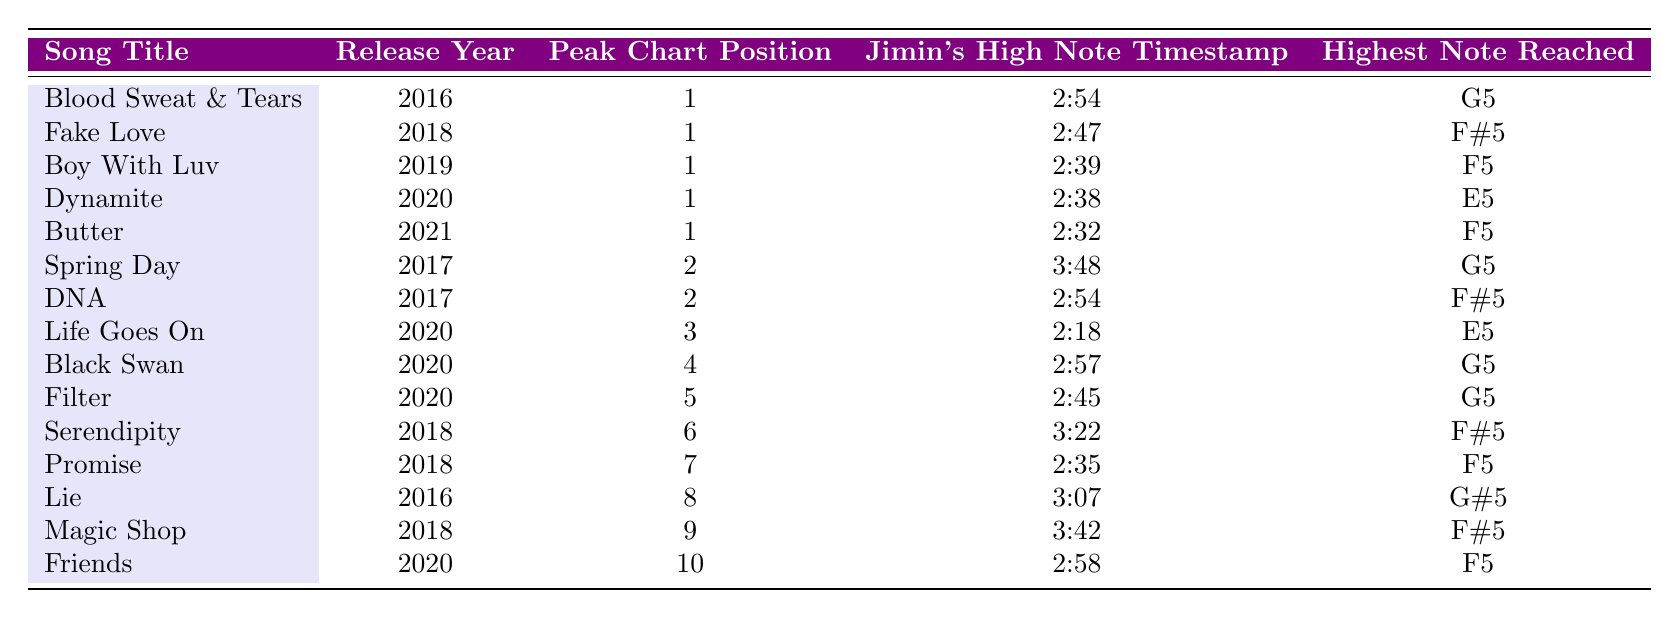What is the highest chart position achieved by "Blood Sweat & Tears"? The table lists the peak chart position for each song. For "Blood Sweat & Tears," the peak chart position is 1.
Answer: 1 Which song features Jimin's high note at the timestamp of 2:45? By looking at the timestamp column, the song "Filter" has Jimin's high note at 2:45.
Answer: Filter Which songs with a peak position of 2 includes Jimin's high notes? There are two songs with a peak position of 2: "Spring Day" and "DNA".
Answer: Spring Day, DNA What is the highest note reached in "Serendipity"? The table indicates that "Serendipity" features Jimin's highest note at F#5.
Answer: F#5 Which song released in 2020 had the lowest peak chart position? Looking at the year 2020, "Life Goes On" has the lowest peak position at 3 among the songs released that year.
Answer: Life Goes On If you sum the chart positions of all songs featuring Jimin's high notes, what is the total? By adding the peak positions (1 + 1 + 1 + 1 + 1 + 2 + 2 + 3 + 4 + 5 + 6 + 7 + 8 + 9 + 10), the total is 60.
Answer: 60 What year did "Dynamite" get released? The table states that "Dynamite" was released in 2020.
Answer: 2020 Which song has the highest note of G#5 and what is its peak position? According to the table, "Lie" has the highest note of G#5 and its peak position is 8.
Answer: Lie, 8 Are there more songs with peak positions of 1 or 2 featuring Jimin's high notes? There are 5 songs with a peak position of 1 ("Blood Sweat & Tears," "Fake Love," "Boy With Luv," "Dynamite," "Butter") and 2 songs with a peak position of 2 ("Spring Day" and "DNA"). Thus, there are more songs with peak position 1.
Answer: More songs with peak position 1 What is the total number of songs featuring Jimin's high notes that reached top 5 on the charts? In the table, the songs that reached the top 5 are "Blood Sweat & Tears," "Fake Love," "Boy With Luv," "Dynamite," "Butter," "Spring Day," "DNA," "Life Goes On," "Black Swan," and "Filter," totaling 9 songs.
Answer: 9 